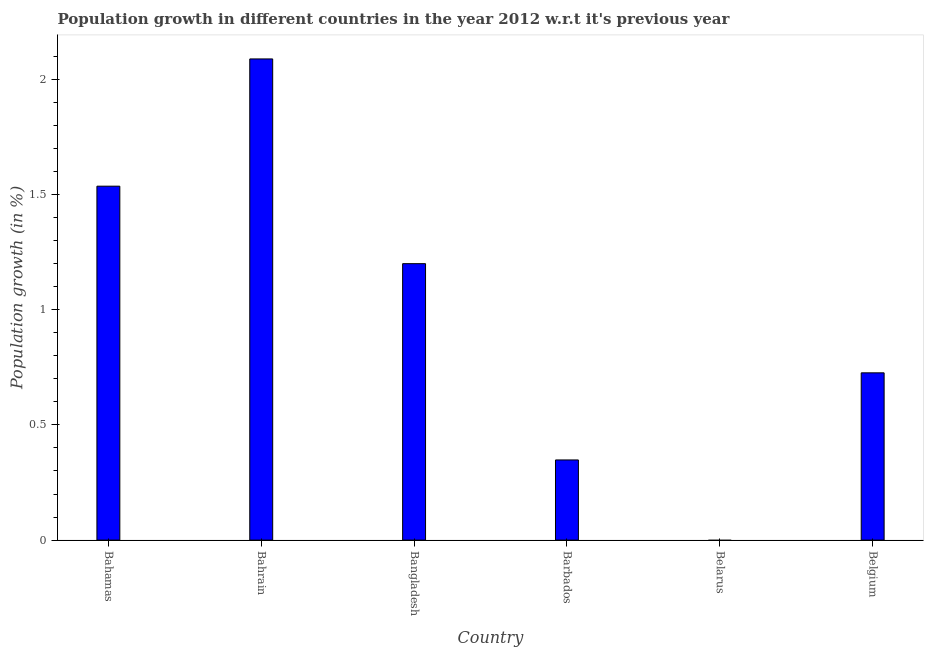Does the graph contain any zero values?
Your answer should be very brief. Yes. Does the graph contain grids?
Your answer should be very brief. No. What is the title of the graph?
Offer a terse response. Population growth in different countries in the year 2012 w.r.t it's previous year. What is the label or title of the Y-axis?
Offer a very short reply. Population growth (in %). What is the population growth in Bangladesh?
Your answer should be very brief. 1.2. Across all countries, what is the maximum population growth?
Your answer should be compact. 2.09. In which country was the population growth maximum?
Provide a succinct answer. Bahrain. What is the sum of the population growth?
Provide a short and direct response. 5.9. What is the difference between the population growth in Bahrain and Belgium?
Provide a succinct answer. 1.36. What is the median population growth?
Your answer should be compact. 0.96. What is the ratio of the population growth in Bahamas to that in Bahrain?
Your response must be concise. 0.74. Is the difference between the population growth in Bahrain and Belgium greater than the difference between any two countries?
Give a very brief answer. No. What is the difference between the highest and the second highest population growth?
Offer a terse response. 0.55. What is the difference between the highest and the lowest population growth?
Ensure brevity in your answer.  2.09. How many bars are there?
Offer a very short reply. 5. How many countries are there in the graph?
Provide a short and direct response. 6. What is the difference between two consecutive major ticks on the Y-axis?
Your response must be concise. 0.5. Are the values on the major ticks of Y-axis written in scientific E-notation?
Make the answer very short. No. What is the Population growth (in %) of Bahamas?
Make the answer very short. 1.54. What is the Population growth (in %) of Bahrain?
Give a very brief answer. 2.09. What is the Population growth (in %) in Bangladesh?
Your response must be concise. 1.2. What is the Population growth (in %) of Barbados?
Your answer should be very brief. 0.35. What is the Population growth (in %) of Belgium?
Your answer should be compact. 0.73. What is the difference between the Population growth (in %) in Bahamas and Bahrain?
Your response must be concise. -0.55. What is the difference between the Population growth (in %) in Bahamas and Bangladesh?
Your response must be concise. 0.34. What is the difference between the Population growth (in %) in Bahamas and Barbados?
Provide a succinct answer. 1.19. What is the difference between the Population growth (in %) in Bahamas and Belgium?
Your response must be concise. 0.81. What is the difference between the Population growth (in %) in Bahrain and Bangladesh?
Provide a succinct answer. 0.89. What is the difference between the Population growth (in %) in Bahrain and Barbados?
Your answer should be compact. 1.74. What is the difference between the Population growth (in %) in Bahrain and Belgium?
Keep it short and to the point. 1.36. What is the difference between the Population growth (in %) in Bangladesh and Barbados?
Provide a short and direct response. 0.85. What is the difference between the Population growth (in %) in Bangladesh and Belgium?
Offer a terse response. 0.47. What is the difference between the Population growth (in %) in Barbados and Belgium?
Offer a very short reply. -0.38. What is the ratio of the Population growth (in %) in Bahamas to that in Bahrain?
Your answer should be compact. 0.74. What is the ratio of the Population growth (in %) in Bahamas to that in Bangladesh?
Ensure brevity in your answer.  1.28. What is the ratio of the Population growth (in %) in Bahamas to that in Barbados?
Give a very brief answer. 4.42. What is the ratio of the Population growth (in %) in Bahamas to that in Belgium?
Your answer should be very brief. 2.12. What is the ratio of the Population growth (in %) in Bahrain to that in Bangladesh?
Ensure brevity in your answer.  1.74. What is the ratio of the Population growth (in %) in Bahrain to that in Barbados?
Ensure brevity in your answer.  6. What is the ratio of the Population growth (in %) in Bahrain to that in Belgium?
Provide a succinct answer. 2.88. What is the ratio of the Population growth (in %) in Bangladesh to that in Barbados?
Provide a succinct answer. 3.45. What is the ratio of the Population growth (in %) in Bangladesh to that in Belgium?
Make the answer very short. 1.65. What is the ratio of the Population growth (in %) in Barbados to that in Belgium?
Offer a very short reply. 0.48. 